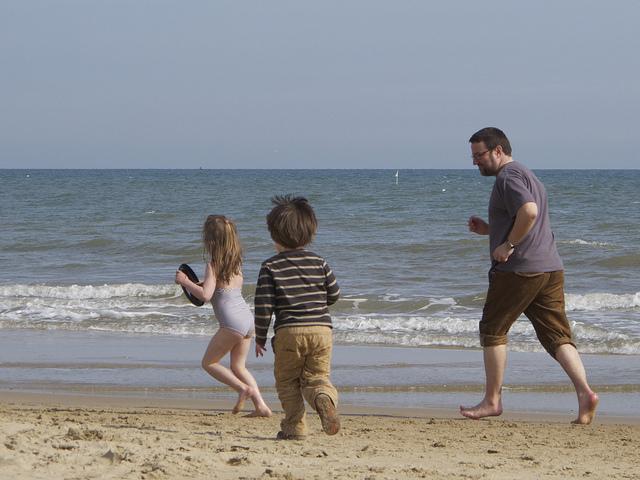Is the little girl holding anything?
Keep it brief. Yes. Are they standing on sand?
Keep it brief. Yes. What color is the shirt's design?
Quick response, please. Striped. Which man is in blue?
Quick response, please. Adult. Are there any sharks in the water?
Write a very short answer. No. How many people are holding a frisbee?
Keep it brief. 1. Are they going surfing?
Write a very short answer. No. Is the man wearing glasses?
Concise answer only. Yes. How are the children related to the man?
Quick response, please. His kids. 